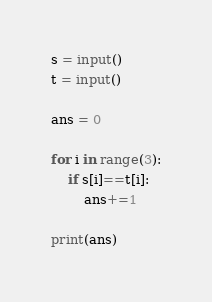<code> <loc_0><loc_0><loc_500><loc_500><_Python_>s = input()
t = input()
 
ans = 0
 
for i in range(3):
    if s[i]==t[i]:
        ans+=1
 
print(ans)</code> 